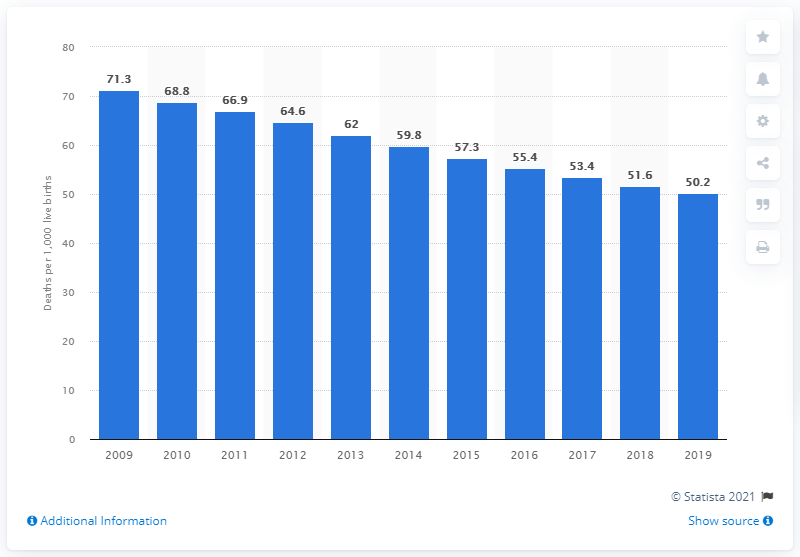Identify some key points in this picture. In 2019, the infant mortality rate in Cameroon was 50.2 deaths per 1,000 live births. 